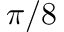<formula> <loc_0><loc_0><loc_500><loc_500>\pi / 8</formula> 